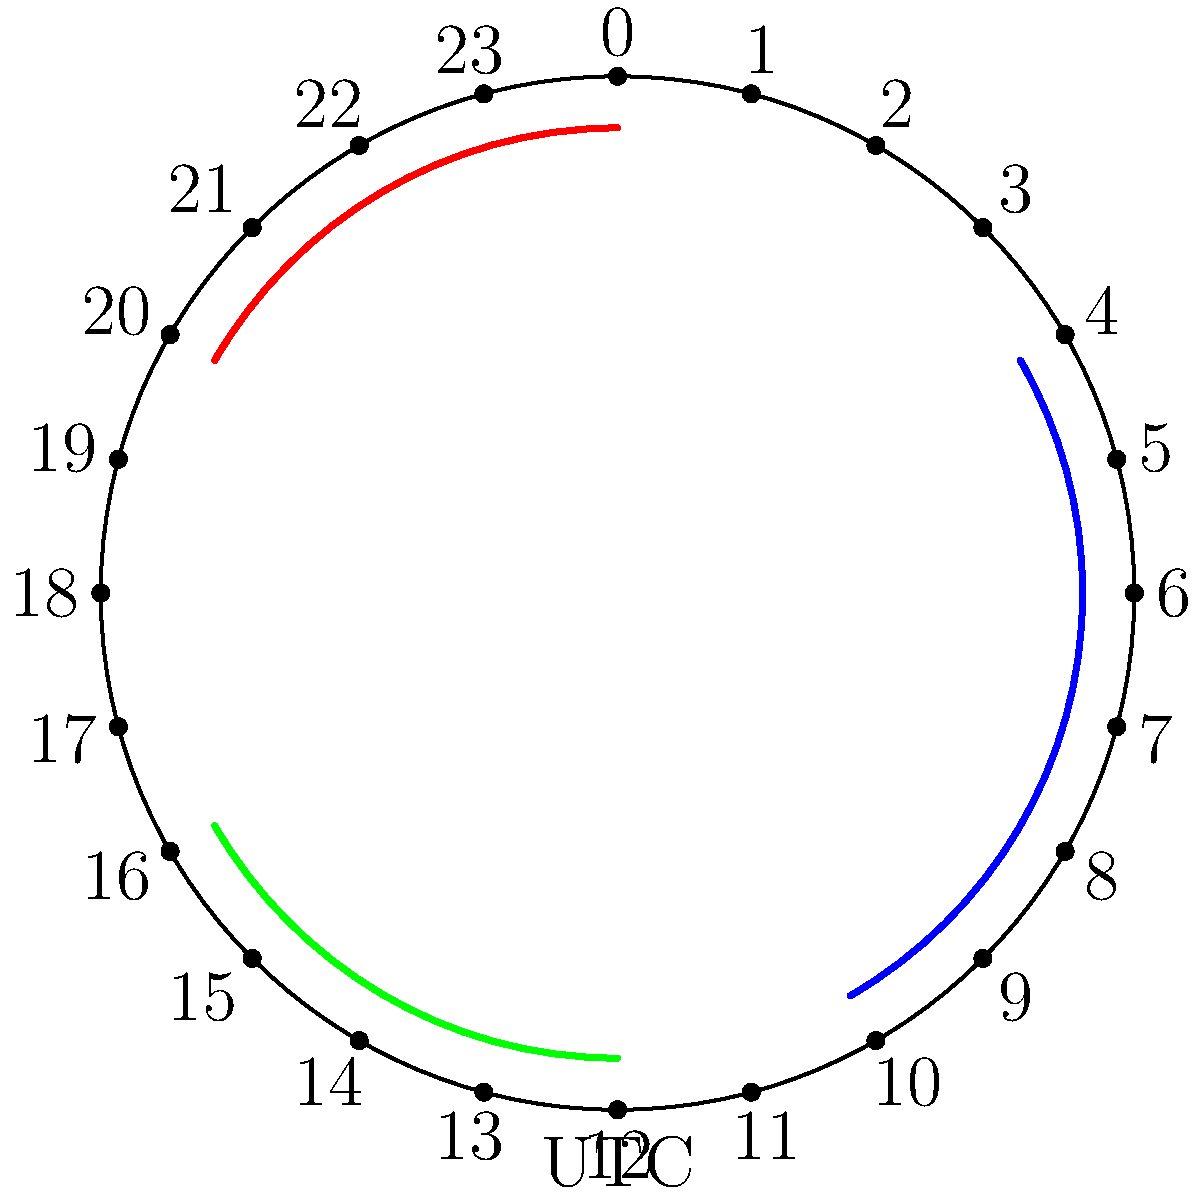A Salesforce app needs to be updated across three different time zones. The update process takes 2 hours and must be completed during non-business hours (9 PM to 5 AM local time) for each region. The blue arc represents the update window for Region A (UTC-4), the red arc for Region B (UTC+2), and the green arc for Region C (UTC+10). What is the total central angle, in degrees, that represents the combined update windows on the 24-hour clock face? Let's approach this step-by-step:

1. First, we need to calculate the central angle for each region's update window:
   - Each hour on a 24-hour clock represents $\frac{360°}{24} = 15°$
   - The update window is from 9 PM to 5 AM, which is 8 hours
   - So, each update window spans $8 \times 15° = 120°$

2. Now, let's determine the position of each update window on the clock:
   - Region A (UTC-4): 9 PM UTC-4 = 1 AM UTC, 5 AM UTC-4 = 9 AM UTC
   - Region B (UTC+2): 9 PM UTC+2 = 7 PM UTC, 5 AM UTC+2 = 3 AM UTC
   - Region C (UTC+10): 9 PM UTC+10 = 11 AM UTC, 5 AM UTC+10 = 7 PM UTC

3. We can see from the clock face that:
   - The blue arc (Region A) spans from 1 AM to 9 AM (120°)
   - The red arc (Region B) spans from 7 PM to 3 AM (120°)
   - The green arc (Region C) spans from 11 AM to 7 PM (120°)

4. To find the total central angle, we need to add these up, considering any overlaps:
   - In this case, there are no overlaps between the arcs
   - Total central angle = $120° + 120° + 120° = 360°$

Therefore, the total central angle representing the combined update windows is 360°.
Answer: 360° 